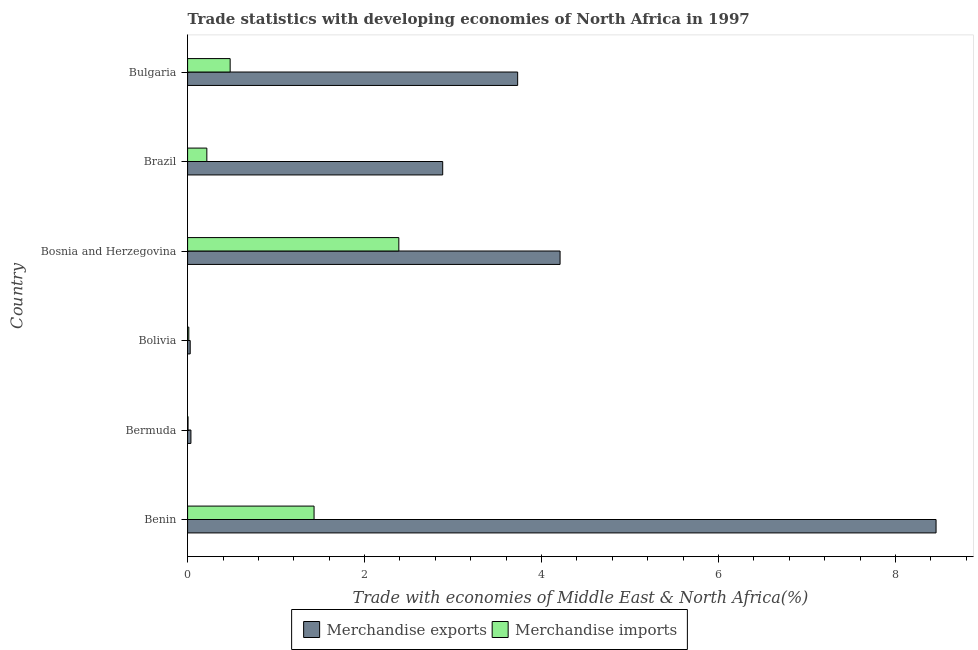How many different coloured bars are there?
Your answer should be very brief. 2. How many bars are there on the 1st tick from the bottom?
Your answer should be compact. 2. What is the merchandise exports in Bermuda?
Offer a very short reply. 0.04. Across all countries, what is the maximum merchandise exports?
Your answer should be very brief. 8.46. Across all countries, what is the minimum merchandise imports?
Keep it short and to the point. 0.01. In which country was the merchandise imports maximum?
Keep it short and to the point. Bosnia and Herzegovina. In which country was the merchandise imports minimum?
Ensure brevity in your answer.  Bermuda. What is the total merchandise imports in the graph?
Offer a terse response. 4.53. What is the difference between the merchandise exports in Benin and that in Bosnia and Herzegovina?
Give a very brief answer. 4.25. What is the difference between the merchandise imports in Benin and the merchandise exports in Brazil?
Offer a terse response. -1.45. What is the average merchandise exports per country?
Provide a succinct answer. 3.23. What is the difference between the merchandise imports and merchandise exports in Brazil?
Your answer should be compact. -2.67. What is the ratio of the merchandise exports in Benin to that in Bolivia?
Offer a very short reply. 287.69. What is the difference between the highest and the second highest merchandise imports?
Your answer should be very brief. 0.96. What is the difference between the highest and the lowest merchandise exports?
Provide a short and direct response. 8.43. What does the 2nd bar from the top in Bosnia and Herzegovina represents?
Your answer should be very brief. Merchandise exports. How many bars are there?
Provide a short and direct response. 12. How many countries are there in the graph?
Provide a short and direct response. 6. What is the difference between two consecutive major ticks on the X-axis?
Your answer should be very brief. 2. Are the values on the major ticks of X-axis written in scientific E-notation?
Your response must be concise. No. Does the graph contain any zero values?
Offer a terse response. No. Does the graph contain grids?
Provide a succinct answer. No. Where does the legend appear in the graph?
Ensure brevity in your answer.  Bottom center. How are the legend labels stacked?
Offer a very short reply. Horizontal. What is the title of the graph?
Keep it short and to the point. Trade statistics with developing economies of North Africa in 1997. Does "Gasoline" appear as one of the legend labels in the graph?
Provide a short and direct response. No. What is the label or title of the X-axis?
Your answer should be very brief. Trade with economies of Middle East & North Africa(%). What is the label or title of the Y-axis?
Ensure brevity in your answer.  Country. What is the Trade with economies of Middle East & North Africa(%) of Merchandise exports in Benin?
Give a very brief answer. 8.46. What is the Trade with economies of Middle East & North Africa(%) of Merchandise imports in Benin?
Make the answer very short. 1.43. What is the Trade with economies of Middle East & North Africa(%) in Merchandise exports in Bermuda?
Your answer should be very brief. 0.04. What is the Trade with economies of Middle East & North Africa(%) of Merchandise imports in Bermuda?
Provide a succinct answer. 0.01. What is the Trade with economies of Middle East & North Africa(%) in Merchandise exports in Bolivia?
Give a very brief answer. 0.03. What is the Trade with economies of Middle East & North Africa(%) in Merchandise imports in Bolivia?
Give a very brief answer. 0.01. What is the Trade with economies of Middle East & North Africa(%) of Merchandise exports in Bosnia and Herzegovina?
Make the answer very short. 4.21. What is the Trade with economies of Middle East & North Africa(%) in Merchandise imports in Bosnia and Herzegovina?
Your answer should be very brief. 2.39. What is the Trade with economies of Middle East & North Africa(%) of Merchandise exports in Brazil?
Offer a terse response. 2.88. What is the Trade with economies of Middle East & North Africa(%) in Merchandise imports in Brazil?
Make the answer very short. 0.22. What is the Trade with economies of Middle East & North Africa(%) of Merchandise exports in Bulgaria?
Keep it short and to the point. 3.73. What is the Trade with economies of Middle East & North Africa(%) of Merchandise imports in Bulgaria?
Make the answer very short. 0.48. Across all countries, what is the maximum Trade with economies of Middle East & North Africa(%) of Merchandise exports?
Make the answer very short. 8.46. Across all countries, what is the maximum Trade with economies of Middle East & North Africa(%) of Merchandise imports?
Your response must be concise. 2.39. Across all countries, what is the minimum Trade with economies of Middle East & North Africa(%) of Merchandise exports?
Your answer should be compact. 0.03. Across all countries, what is the minimum Trade with economies of Middle East & North Africa(%) in Merchandise imports?
Offer a very short reply. 0.01. What is the total Trade with economies of Middle East & North Africa(%) of Merchandise exports in the graph?
Offer a terse response. 19.35. What is the total Trade with economies of Middle East & North Africa(%) in Merchandise imports in the graph?
Offer a terse response. 4.53. What is the difference between the Trade with economies of Middle East & North Africa(%) of Merchandise exports in Benin and that in Bermuda?
Make the answer very short. 8.42. What is the difference between the Trade with economies of Middle East & North Africa(%) in Merchandise imports in Benin and that in Bermuda?
Keep it short and to the point. 1.42. What is the difference between the Trade with economies of Middle East & North Africa(%) of Merchandise exports in Benin and that in Bolivia?
Offer a very short reply. 8.43. What is the difference between the Trade with economies of Middle East & North Africa(%) of Merchandise imports in Benin and that in Bolivia?
Ensure brevity in your answer.  1.42. What is the difference between the Trade with economies of Middle East & North Africa(%) in Merchandise exports in Benin and that in Bosnia and Herzegovina?
Offer a terse response. 4.25. What is the difference between the Trade with economies of Middle East & North Africa(%) in Merchandise imports in Benin and that in Bosnia and Herzegovina?
Provide a short and direct response. -0.96. What is the difference between the Trade with economies of Middle East & North Africa(%) of Merchandise exports in Benin and that in Brazil?
Your response must be concise. 5.58. What is the difference between the Trade with economies of Middle East & North Africa(%) of Merchandise imports in Benin and that in Brazil?
Keep it short and to the point. 1.21. What is the difference between the Trade with economies of Middle East & North Africa(%) in Merchandise exports in Benin and that in Bulgaria?
Make the answer very short. 4.73. What is the difference between the Trade with economies of Middle East & North Africa(%) in Merchandise imports in Benin and that in Bulgaria?
Offer a terse response. 0.95. What is the difference between the Trade with economies of Middle East & North Africa(%) in Merchandise exports in Bermuda and that in Bolivia?
Your answer should be compact. 0.01. What is the difference between the Trade with economies of Middle East & North Africa(%) in Merchandise imports in Bermuda and that in Bolivia?
Make the answer very short. -0.01. What is the difference between the Trade with economies of Middle East & North Africa(%) in Merchandise exports in Bermuda and that in Bosnia and Herzegovina?
Provide a succinct answer. -4.17. What is the difference between the Trade with economies of Middle East & North Africa(%) of Merchandise imports in Bermuda and that in Bosnia and Herzegovina?
Provide a succinct answer. -2.38. What is the difference between the Trade with economies of Middle East & North Africa(%) in Merchandise exports in Bermuda and that in Brazil?
Make the answer very short. -2.85. What is the difference between the Trade with economies of Middle East & North Africa(%) in Merchandise imports in Bermuda and that in Brazil?
Offer a terse response. -0.21. What is the difference between the Trade with economies of Middle East & North Africa(%) of Merchandise exports in Bermuda and that in Bulgaria?
Offer a very short reply. -3.69. What is the difference between the Trade with economies of Middle East & North Africa(%) in Merchandise imports in Bermuda and that in Bulgaria?
Make the answer very short. -0.48. What is the difference between the Trade with economies of Middle East & North Africa(%) in Merchandise exports in Bolivia and that in Bosnia and Herzegovina?
Keep it short and to the point. -4.18. What is the difference between the Trade with economies of Middle East & North Africa(%) of Merchandise imports in Bolivia and that in Bosnia and Herzegovina?
Make the answer very short. -2.37. What is the difference between the Trade with economies of Middle East & North Africa(%) of Merchandise exports in Bolivia and that in Brazil?
Provide a succinct answer. -2.85. What is the difference between the Trade with economies of Middle East & North Africa(%) in Merchandise imports in Bolivia and that in Brazil?
Give a very brief answer. -0.2. What is the difference between the Trade with economies of Middle East & North Africa(%) in Merchandise exports in Bolivia and that in Bulgaria?
Offer a terse response. -3.7. What is the difference between the Trade with economies of Middle East & North Africa(%) of Merchandise imports in Bolivia and that in Bulgaria?
Keep it short and to the point. -0.47. What is the difference between the Trade with economies of Middle East & North Africa(%) in Merchandise exports in Bosnia and Herzegovina and that in Brazil?
Your answer should be very brief. 1.33. What is the difference between the Trade with economies of Middle East & North Africa(%) of Merchandise imports in Bosnia and Herzegovina and that in Brazil?
Provide a succinct answer. 2.17. What is the difference between the Trade with economies of Middle East & North Africa(%) in Merchandise exports in Bosnia and Herzegovina and that in Bulgaria?
Your answer should be compact. 0.48. What is the difference between the Trade with economies of Middle East & North Africa(%) of Merchandise imports in Bosnia and Herzegovina and that in Bulgaria?
Give a very brief answer. 1.91. What is the difference between the Trade with economies of Middle East & North Africa(%) in Merchandise exports in Brazil and that in Bulgaria?
Offer a terse response. -0.85. What is the difference between the Trade with economies of Middle East & North Africa(%) of Merchandise imports in Brazil and that in Bulgaria?
Your response must be concise. -0.26. What is the difference between the Trade with economies of Middle East & North Africa(%) in Merchandise exports in Benin and the Trade with economies of Middle East & North Africa(%) in Merchandise imports in Bermuda?
Your response must be concise. 8.45. What is the difference between the Trade with economies of Middle East & North Africa(%) in Merchandise exports in Benin and the Trade with economies of Middle East & North Africa(%) in Merchandise imports in Bolivia?
Your response must be concise. 8.44. What is the difference between the Trade with economies of Middle East & North Africa(%) of Merchandise exports in Benin and the Trade with economies of Middle East & North Africa(%) of Merchandise imports in Bosnia and Herzegovina?
Your answer should be very brief. 6.07. What is the difference between the Trade with economies of Middle East & North Africa(%) of Merchandise exports in Benin and the Trade with economies of Middle East & North Africa(%) of Merchandise imports in Brazil?
Your answer should be very brief. 8.24. What is the difference between the Trade with economies of Middle East & North Africa(%) in Merchandise exports in Benin and the Trade with economies of Middle East & North Africa(%) in Merchandise imports in Bulgaria?
Make the answer very short. 7.98. What is the difference between the Trade with economies of Middle East & North Africa(%) in Merchandise exports in Bermuda and the Trade with economies of Middle East & North Africa(%) in Merchandise imports in Bolivia?
Keep it short and to the point. 0.02. What is the difference between the Trade with economies of Middle East & North Africa(%) in Merchandise exports in Bermuda and the Trade with economies of Middle East & North Africa(%) in Merchandise imports in Bosnia and Herzegovina?
Your response must be concise. -2.35. What is the difference between the Trade with economies of Middle East & North Africa(%) of Merchandise exports in Bermuda and the Trade with economies of Middle East & North Africa(%) of Merchandise imports in Brazil?
Ensure brevity in your answer.  -0.18. What is the difference between the Trade with economies of Middle East & North Africa(%) in Merchandise exports in Bermuda and the Trade with economies of Middle East & North Africa(%) in Merchandise imports in Bulgaria?
Keep it short and to the point. -0.44. What is the difference between the Trade with economies of Middle East & North Africa(%) in Merchandise exports in Bolivia and the Trade with economies of Middle East & North Africa(%) in Merchandise imports in Bosnia and Herzegovina?
Your answer should be compact. -2.36. What is the difference between the Trade with economies of Middle East & North Africa(%) in Merchandise exports in Bolivia and the Trade with economies of Middle East & North Africa(%) in Merchandise imports in Brazil?
Provide a succinct answer. -0.19. What is the difference between the Trade with economies of Middle East & North Africa(%) of Merchandise exports in Bolivia and the Trade with economies of Middle East & North Africa(%) of Merchandise imports in Bulgaria?
Provide a succinct answer. -0.45. What is the difference between the Trade with economies of Middle East & North Africa(%) of Merchandise exports in Bosnia and Herzegovina and the Trade with economies of Middle East & North Africa(%) of Merchandise imports in Brazil?
Your answer should be very brief. 3.99. What is the difference between the Trade with economies of Middle East & North Africa(%) in Merchandise exports in Bosnia and Herzegovina and the Trade with economies of Middle East & North Africa(%) in Merchandise imports in Bulgaria?
Ensure brevity in your answer.  3.73. What is the difference between the Trade with economies of Middle East & North Africa(%) of Merchandise exports in Brazil and the Trade with economies of Middle East & North Africa(%) of Merchandise imports in Bulgaria?
Offer a terse response. 2.4. What is the average Trade with economies of Middle East & North Africa(%) of Merchandise exports per country?
Offer a terse response. 3.22. What is the average Trade with economies of Middle East & North Africa(%) of Merchandise imports per country?
Make the answer very short. 0.76. What is the difference between the Trade with economies of Middle East & North Africa(%) of Merchandise exports and Trade with economies of Middle East & North Africa(%) of Merchandise imports in Benin?
Your answer should be compact. 7.03. What is the difference between the Trade with economies of Middle East & North Africa(%) in Merchandise exports and Trade with economies of Middle East & North Africa(%) in Merchandise imports in Bermuda?
Keep it short and to the point. 0.03. What is the difference between the Trade with economies of Middle East & North Africa(%) in Merchandise exports and Trade with economies of Middle East & North Africa(%) in Merchandise imports in Bolivia?
Give a very brief answer. 0.02. What is the difference between the Trade with economies of Middle East & North Africa(%) of Merchandise exports and Trade with economies of Middle East & North Africa(%) of Merchandise imports in Bosnia and Herzegovina?
Offer a very short reply. 1.82. What is the difference between the Trade with economies of Middle East & North Africa(%) of Merchandise exports and Trade with economies of Middle East & North Africa(%) of Merchandise imports in Brazil?
Your response must be concise. 2.67. What is the difference between the Trade with economies of Middle East & North Africa(%) of Merchandise exports and Trade with economies of Middle East & North Africa(%) of Merchandise imports in Bulgaria?
Offer a terse response. 3.25. What is the ratio of the Trade with economies of Middle East & North Africa(%) in Merchandise exports in Benin to that in Bermuda?
Your answer should be compact. 224.71. What is the ratio of the Trade with economies of Middle East & North Africa(%) in Merchandise imports in Benin to that in Bermuda?
Give a very brief answer. 285.57. What is the ratio of the Trade with economies of Middle East & North Africa(%) of Merchandise exports in Benin to that in Bolivia?
Your response must be concise. 287.69. What is the ratio of the Trade with economies of Middle East & North Africa(%) in Merchandise imports in Benin to that in Bolivia?
Your answer should be compact. 104.04. What is the ratio of the Trade with economies of Middle East & North Africa(%) in Merchandise exports in Benin to that in Bosnia and Herzegovina?
Offer a very short reply. 2.01. What is the ratio of the Trade with economies of Middle East & North Africa(%) in Merchandise imports in Benin to that in Bosnia and Herzegovina?
Make the answer very short. 0.6. What is the ratio of the Trade with economies of Middle East & North Africa(%) of Merchandise exports in Benin to that in Brazil?
Offer a terse response. 2.93. What is the ratio of the Trade with economies of Middle East & North Africa(%) in Merchandise imports in Benin to that in Brazil?
Provide a succinct answer. 6.57. What is the ratio of the Trade with economies of Middle East & North Africa(%) of Merchandise exports in Benin to that in Bulgaria?
Offer a very short reply. 2.27. What is the ratio of the Trade with economies of Middle East & North Africa(%) of Merchandise imports in Benin to that in Bulgaria?
Provide a short and direct response. 2.97. What is the ratio of the Trade with economies of Middle East & North Africa(%) of Merchandise exports in Bermuda to that in Bolivia?
Keep it short and to the point. 1.28. What is the ratio of the Trade with economies of Middle East & North Africa(%) of Merchandise imports in Bermuda to that in Bolivia?
Offer a very short reply. 0.36. What is the ratio of the Trade with economies of Middle East & North Africa(%) of Merchandise exports in Bermuda to that in Bosnia and Herzegovina?
Your response must be concise. 0.01. What is the ratio of the Trade with economies of Middle East & North Africa(%) in Merchandise imports in Bermuda to that in Bosnia and Herzegovina?
Keep it short and to the point. 0. What is the ratio of the Trade with economies of Middle East & North Africa(%) of Merchandise exports in Bermuda to that in Brazil?
Offer a terse response. 0.01. What is the ratio of the Trade with economies of Middle East & North Africa(%) in Merchandise imports in Bermuda to that in Brazil?
Your answer should be compact. 0.02. What is the ratio of the Trade with economies of Middle East & North Africa(%) of Merchandise exports in Bermuda to that in Bulgaria?
Offer a terse response. 0.01. What is the ratio of the Trade with economies of Middle East & North Africa(%) in Merchandise imports in Bermuda to that in Bulgaria?
Provide a succinct answer. 0.01. What is the ratio of the Trade with economies of Middle East & North Africa(%) of Merchandise exports in Bolivia to that in Bosnia and Herzegovina?
Give a very brief answer. 0.01. What is the ratio of the Trade with economies of Middle East & North Africa(%) of Merchandise imports in Bolivia to that in Bosnia and Herzegovina?
Ensure brevity in your answer.  0.01. What is the ratio of the Trade with economies of Middle East & North Africa(%) of Merchandise exports in Bolivia to that in Brazil?
Give a very brief answer. 0.01. What is the ratio of the Trade with economies of Middle East & North Africa(%) in Merchandise imports in Bolivia to that in Brazil?
Give a very brief answer. 0.06. What is the ratio of the Trade with economies of Middle East & North Africa(%) of Merchandise exports in Bolivia to that in Bulgaria?
Ensure brevity in your answer.  0.01. What is the ratio of the Trade with economies of Middle East & North Africa(%) of Merchandise imports in Bolivia to that in Bulgaria?
Offer a very short reply. 0.03. What is the ratio of the Trade with economies of Middle East & North Africa(%) of Merchandise exports in Bosnia and Herzegovina to that in Brazil?
Your response must be concise. 1.46. What is the ratio of the Trade with economies of Middle East & North Africa(%) of Merchandise imports in Bosnia and Herzegovina to that in Brazil?
Your response must be concise. 10.97. What is the ratio of the Trade with economies of Middle East & North Africa(%) of Merchandise exports in Bosnia and Herzegovina to that in Bulgaria?
Provide a short and direct response. 1.13. What is the ratio of the Trade with economies of Middle East & North Africa(%) in Merchandise imports in Bosnia and Herzegovina to that in Bulgaria?
Keep it short and to the point. 4.96. What is the ratio of the Trade with economies of Middle East & North Africa(%) in Merchandise exports in Brazil to that in Bulgaria?
Your answer should be compact. 0.77. What is the ratio of the Trade with economies of Middle East & North Africa(%) of Merchandise imports in Brazil to that in Bulgaria?
Make the answer very short. 0.45. What is the difference between the highest and the second highest Trade with economies of Middle East & North Africa(%) in Merchandise exports?
Your answer should be compact. 4.25. What is the difference between the highest and the second highest Trade with economies of Middle East & North Africa(%) in Merchandise imports?
Ensure brevity in your answer.  0.96. What is the difference between the highest and the lowest Trade with economies of Middle East & North Africa(%) of Merchandise exports?
Provide a short and direct response. 8.43. What is the difference between the highest and the lowest Trade with economies of Middle East & North Africa(%) in Merchandise imports?
Make the answer very short. 2.38. 